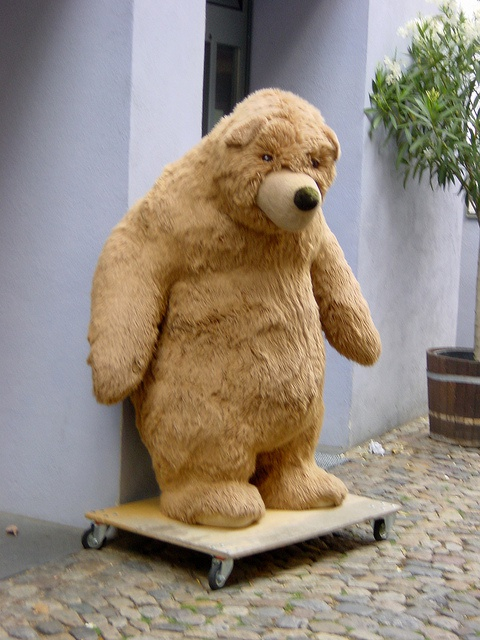Describe the objects in this image and their specific colors. I can see teddy bear in black, olive, tan, and maroon tones and potted plant in black, gray, darkgreen, and lightgray tones in this image. 